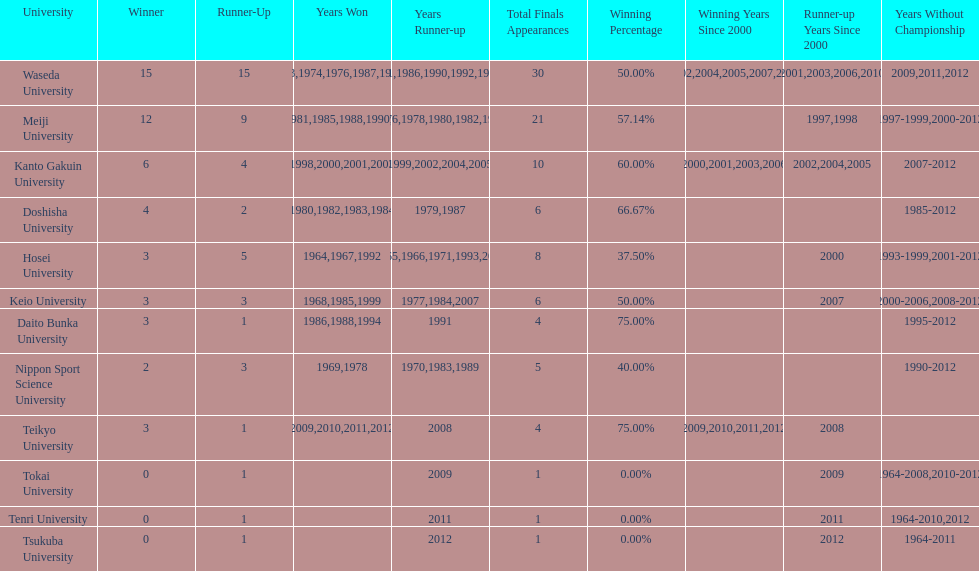I'm looking to parse the entire table for insights. Could you assist me with that? {'header': ['University', 'Winner', 'Runner-Up', 'Years Won', 'Years Runner-up', 'Total Finals Appearances', 'Winning Percentage', 'Winning Years Since 2000', 'Runner-up Years Since 2000', 'Years Without Championship'], 'rows': [['Waseda University', '15', '15', '1965,1966,1968,1970,1971,1973,1974,1976,1987,1989,\\n2002,2004,2005,2007,2008', '1964,1967,1969,1972,1975,1981,1986,1990,1992,1995,\\n1996,2001,2003,2006,2010', '30', '50.00%', '2002,2004,2005,2007,2008', '2001,2003,2006,2010', '2009,2011,2012'], ['Meiji University', '12', '9', '1972,1975,1977,1979,1981,1985,1988,1990,1991,1993,\\n1995,1996', '1973,1974,1976,1978,1980,1982,1994,1997,1998', '21', '57.14%', '', '1997,1998', '1997-1999,2000-2012'], ['Kanto Gakuin University', '6', '4', '1997,1998,2000,2001,2003,2006', '1999,2002,2004,2005', '10', '60.00%', '2000,2001,2003,2006', '2002,2004,2005', '2007-2012'], ['Doshisha University', '4', '2', '1980,1982,1983,1984', '1979,1987', '6', '66.67%', '', '', '1985-2012'], ['Hosei University', '3', '5', '1964,1967,1992', '1965,1966,1971,1993,2000', '8', '37.50%', '', '2000', '1993-1999,2001-2012'], ['Keio University', '3', '3', '1968,1985,1999', '1977,1984,2007', '6', '50.00%', '', '2007', '2000-2006,2008-2012'], ['Daito Bunka University', '3', '1', '1986,1988,1994', '1991', '4', '75.00%', '', '', '1995-2012'], ['Nippon Sport Science University', '2', '3', '1969,1978', '1970,1983,1989', '5', '40.00%', '', '', '1990-2012'], ['Teikyo University', '3', '1', '2009,2010,2011,2012', '2008', '4', '75.00%', '2009,2010,2011,2012', '2008', ''], ['Tokai University', '0', '1', '', '2009', '1', '0.00%', '', '2009', '1964-2008,2010-2012'], ['Tenri University', '0', '1', '', '2011', '1', '0.00%', '', '2011', '1964-2010,2012'], ['Tsukuba University', '0', '1', '', '2012', '1', '0.00%', '', '2012', '1964-2011']]} How many championships does nippon sport science university have 2. 